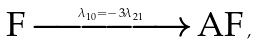Convert formula to latex. <formula><loc_0><loc_0><loc_500><loc_500>\text {F} \xrightarrow { \lambda _ { 1 0 } = - 3 \lambda _ { 2 1 } } \text {AF} \, ,</formula> 